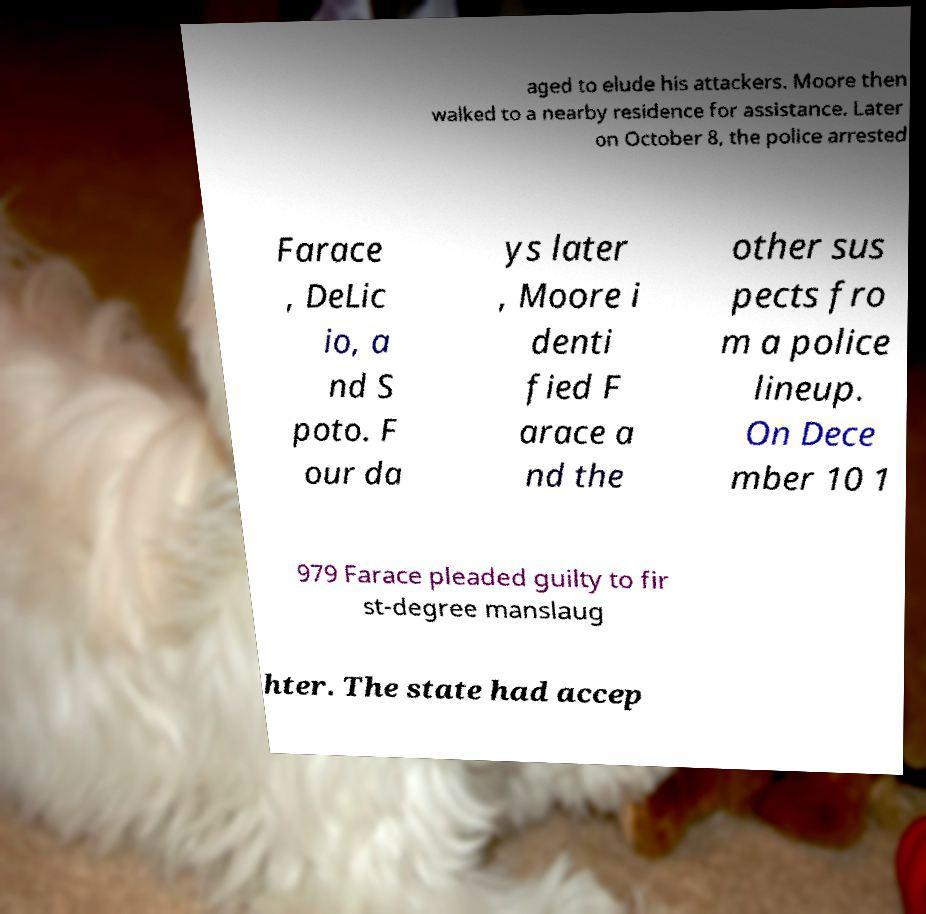What messages or text are displayed in this image? I need them in a readable, typed format. aged to elude his attackers. Moore then walked to a nearby residence for assistance. Later on October 8, the police arrested Farace , DeLic io, a nd S poto. F our da ys later , Moore i denti fied F arace a nd the other sus pects fro m a police lineup. On Dece mber 10 1 979 Farace pleaded guilty to fir st-degree manslaug hter. The state had accep 